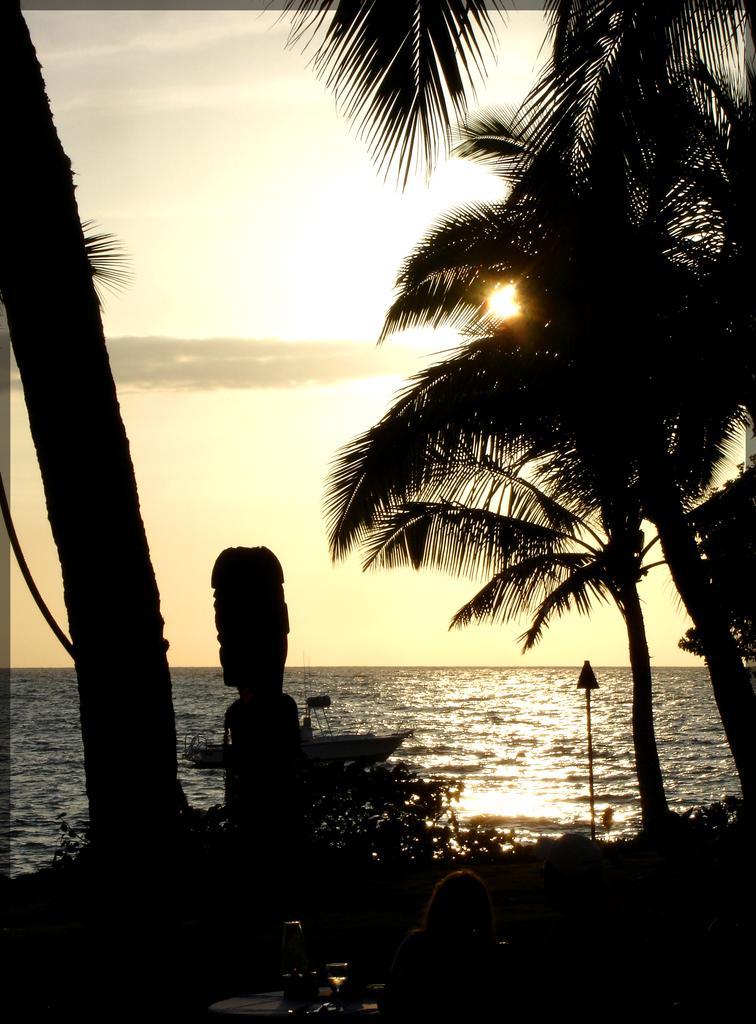Could you give a brief overview of what you see in this image? In this image in the middle there are trees. At the bottom there are plants, boat, water, pole, sign board. At the bottom there is a table on that there is a glass. At the top there is sky and clouds, sun. 